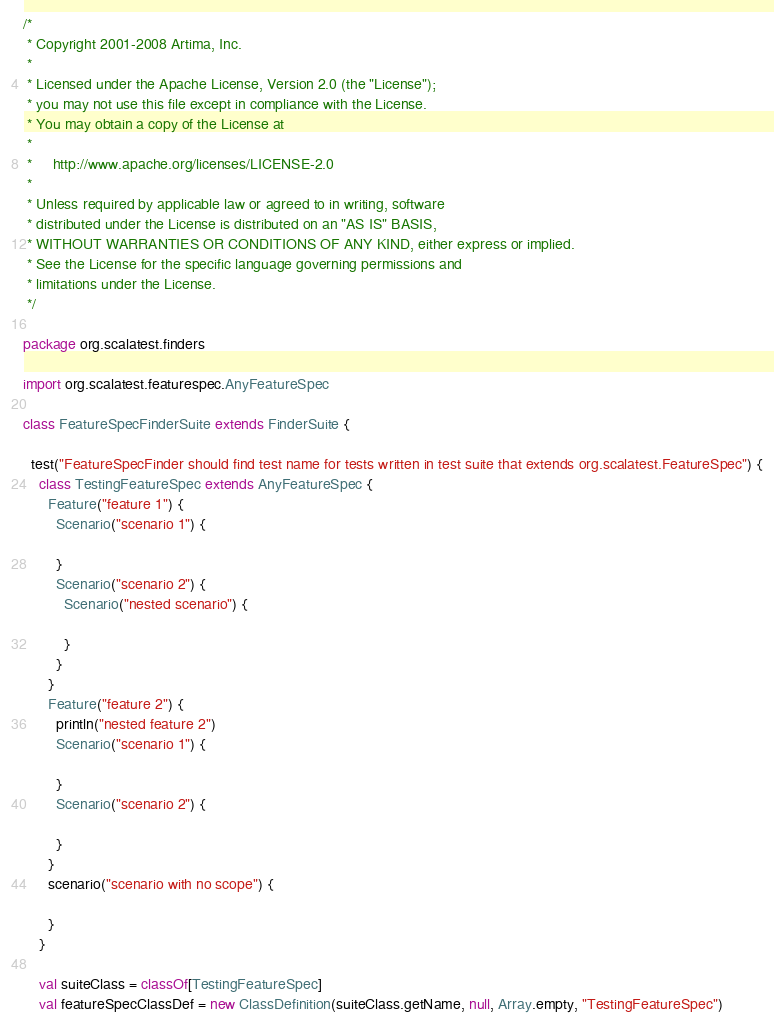<code> <loc_0><loc_0><loc_500><loc_500><_Scala_>/*
 * Copyright 2001-2008 Artima, Inc.
 *
 * Licensed under the Apache License, Version 2.0 (the "License");
 * you may not use this file except in compliance with the License.
 * You may obtain a copy of the License at
 *
 *     http://www.apache.org/licenses/LICENSE-2.0
 *
 * Unless required by applicable law or agreed to in writing, software
 * distributed under the License is distributed on an "AS IS" BASIS,
 * WITHOUT WARRANTIES OR CONDITIONS OF ANY KIND, either express or implied.
 * See the License for the specific language governing permissions and
 * limitations under the License.
 */

package org.scalatest.finders

import org.scalatest.featurespec.AnyFeatureSpec

class FeatureSpecFinderSuite extends FinderSuite {
  
  test("FeatureSpecFinder should find test name for tests written in test suite that extends org.scalatest.FeatureSpec") {
    class TestingFeatureSpec extends AnyFeatureSpec {
      Feature("feature 1") {
        Scenario("scenario 1") {
          
        }
        Scenario("scenario 2") {
          Scenario("nested scenario") {
            
          }
        }
      }
      Feature("feature 2") {
        println("nested feature 2")
        Scenario("scenario 1") {
          
        }
        Scenario("scenario 2") {
          
        }
      }
      scenario("scenario with no scope") {
        
      }
    }
    
    val suiteClass = classOf[TestingFeatureSpec]
    val featureSpecClassDef = new ClassDefinition(suiteClass.getName, null, Array.empty, "TestingFeatureSpec")</code> 